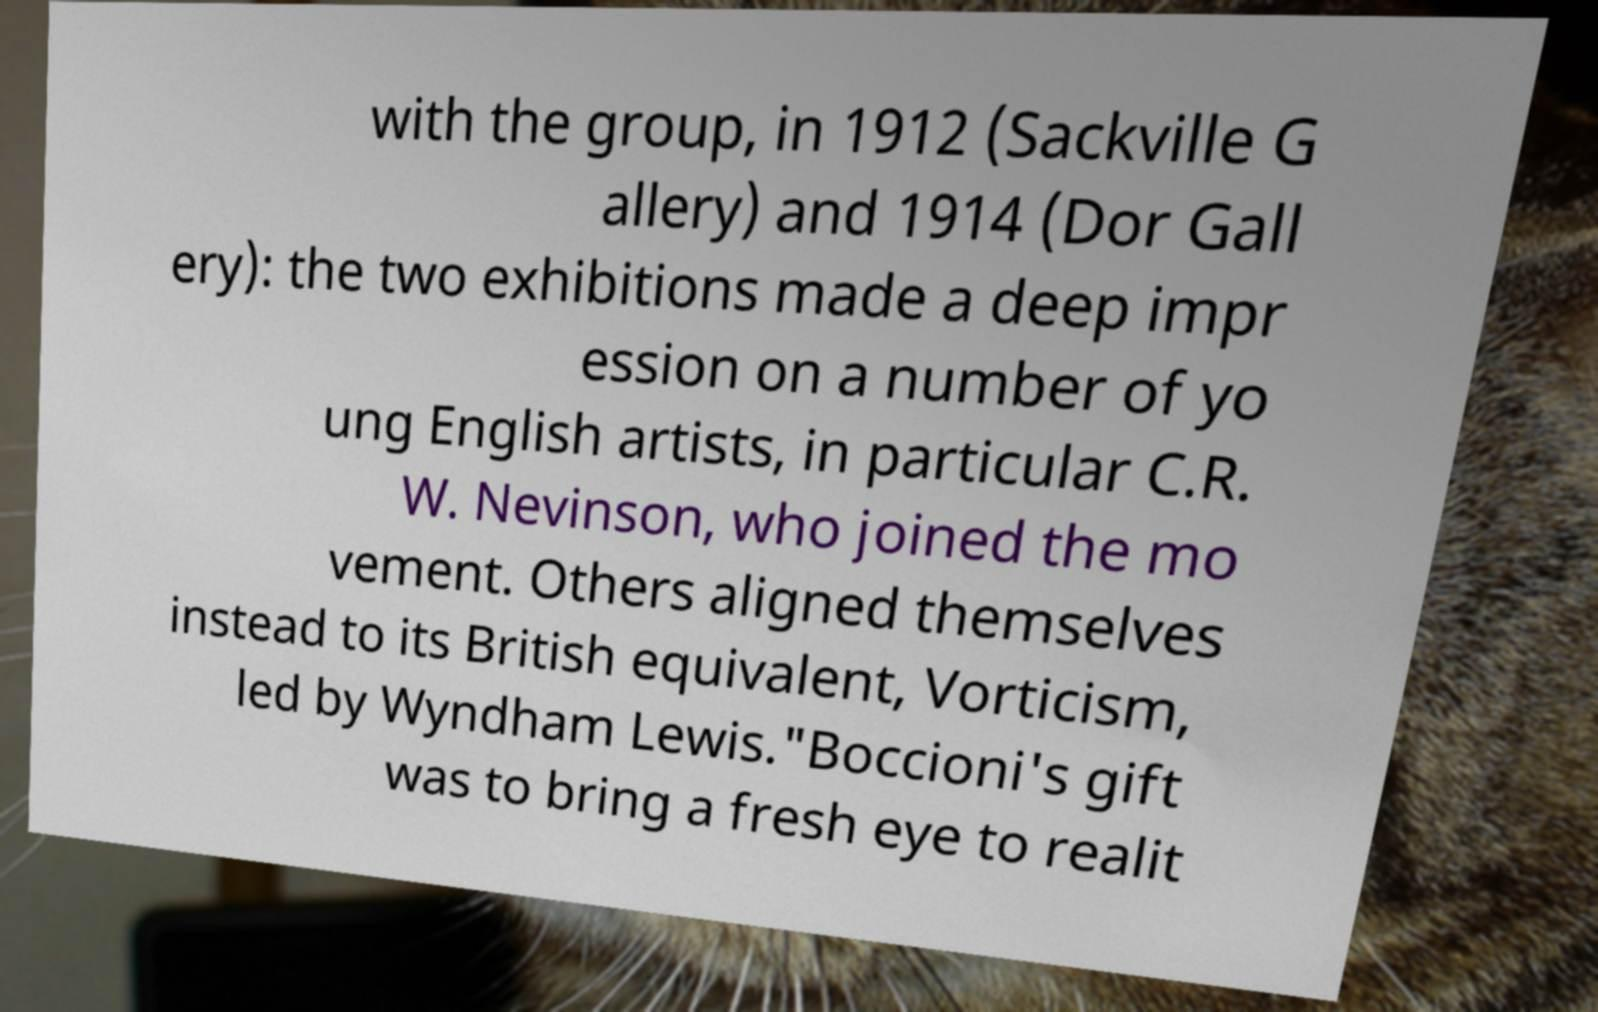Please identify and transcribe the text found in this image. with the group, in 1912 (Sackville G allery) and 1914 (Dor Gall ery): the two exhibitions made a deep impr ession on a number of yo ung English artists, in particular C.R. W. Nevinson, who joined the mo vement. Others aligned themselves instead to its British equivalent, Vorticism, led by Wyndham Lewis."Boccioni's gift was to bring a fresh eye to realit 